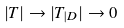Convert formula to latex. <formula><loc_0><loc_0><loc_500><loc_500>| T | \rightarrow | T _ { | D } | \to 0</formula> 